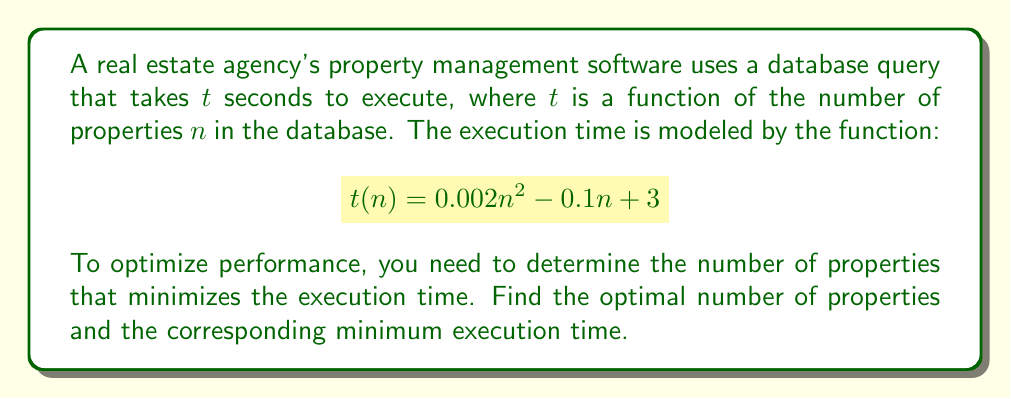Could you help me with this problem? To find the minimum execution time, we need to determine the value of $n$ that minimizes the function $t(n)$. This can be done using calculus by following these steps:

1. Find the derivative of $t(n)$ with respect to $n$:
   $$t'(n) = \frac{d}{dn}(0.002n^2 - 0.1n + 3)$$
   $$t'(n) = 0.004n - 0.1$$

2. Set the derivative equal to zero and solve for $n$:
   $$0.004n - 0.1 = 0$$
   $$0.004n = 0.1$$
   $$n = \frac{0.1}{0.004} = 25$$

3. Verify that this critical point is a minimum by checking the second derivative:
   $$t''(n) = \frac{d}{dn}(0.004n - 0.1) = 0.004$$
   Since $t''(n) > 0$, the critical point is a minimum.

4. Calculate the minimum execution time by substituting $n = 25$ into the original function:
   $$t(25) = 0.002(25)^2 - 0.1(25) + 3$$
   $$t(25) = 0.002(625) - 2.5 + 3$$
   $$t(25) = 1.25 - 2.5 + 3 = 1.75$$

Therefore, the optimal number of properties is 25, and the minimum execution time is 1.75 seconds.
Answer: Optimal number of properties: 25; Minimum execution time: 1.75 seconds 